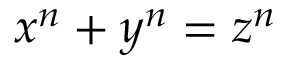Convert formula to latex. <formula><loc_0><loc_0><loc_500><loc_500>x ^ { n } + y ^ { n } = z ^ { n }</formula> 